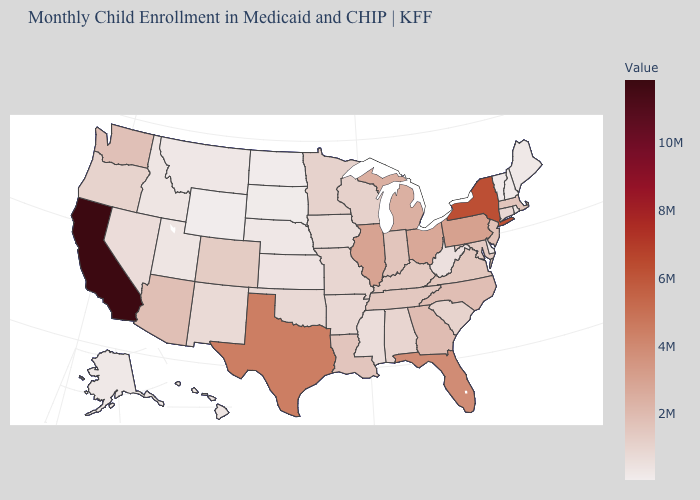Is the legend a continuous bar?
Be succinct. Yes. Does Wyoming have the lowest value in the USA?
Concise answer only. Yes. Is the legend a continuous bar?
Answer briefly. Yes. Does Oklahoma have the highest value in the USA?
Keep it brief. No. Is the legend a continuous bar?
Give a very brief answer. Yes. 